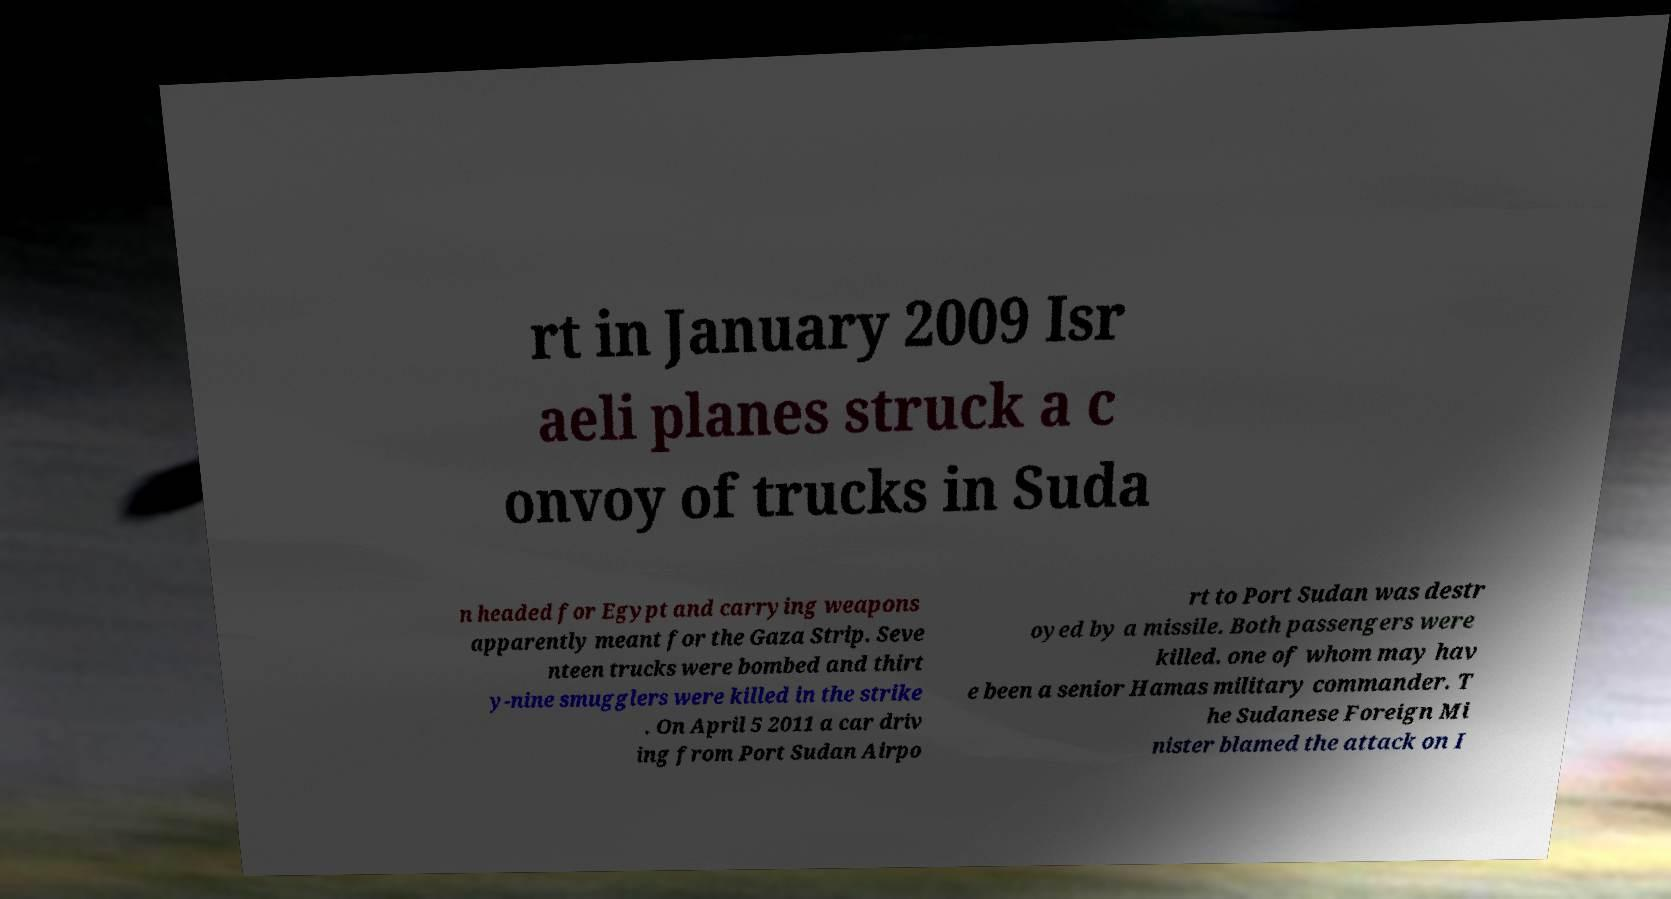For documentation purposes, I need the text within this image transcribed. Could you provide that? rt in January 2009 Isr aeli planes struck a c onvoy of trucks in Suda n headed for Egypt and carrying weapons apparently meant for the Gaza Strip. Seve nteen trucks were bombed and thirt y-nine smugglers were killed in the strike . On April 5 2011 a car driv ing from Port Sudan Airpo rt to Port Sudan was destr oyed by a missile. Both passengers were killed. one of whom may hav e been a senior Hamas military commander. T he Sudanese Foreign Mi nister blamed the attack on I 